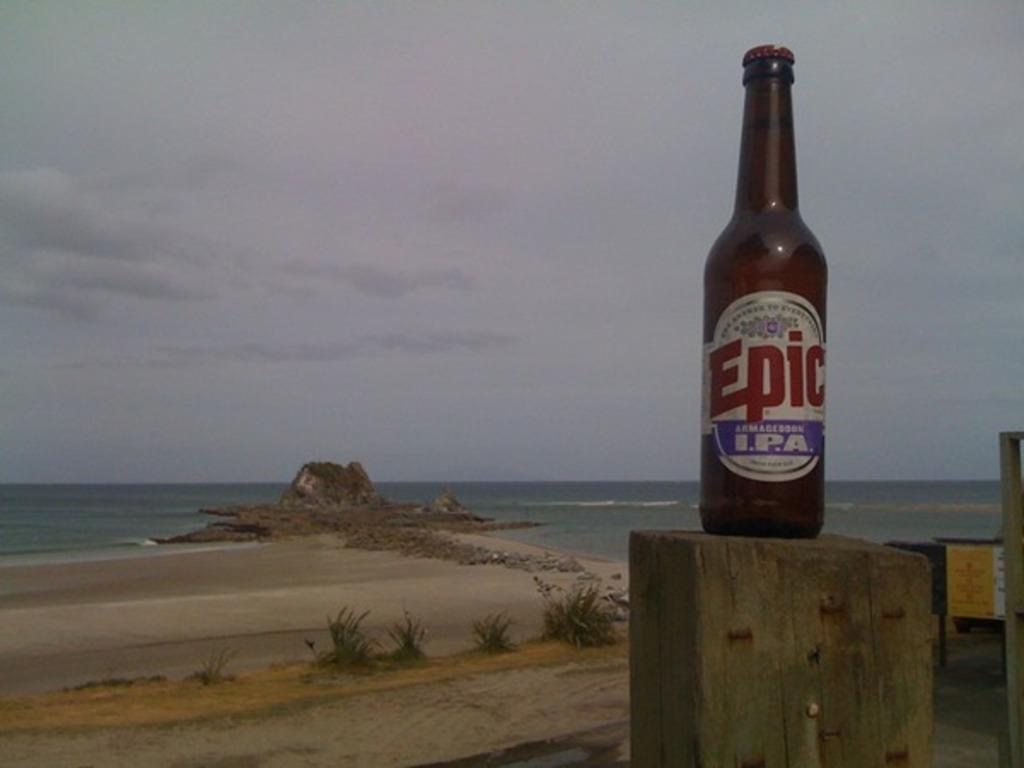<image>
Relay a brief, clear account of the picture shown. A bottle of Epic I.P.A with the ocean in the background. 